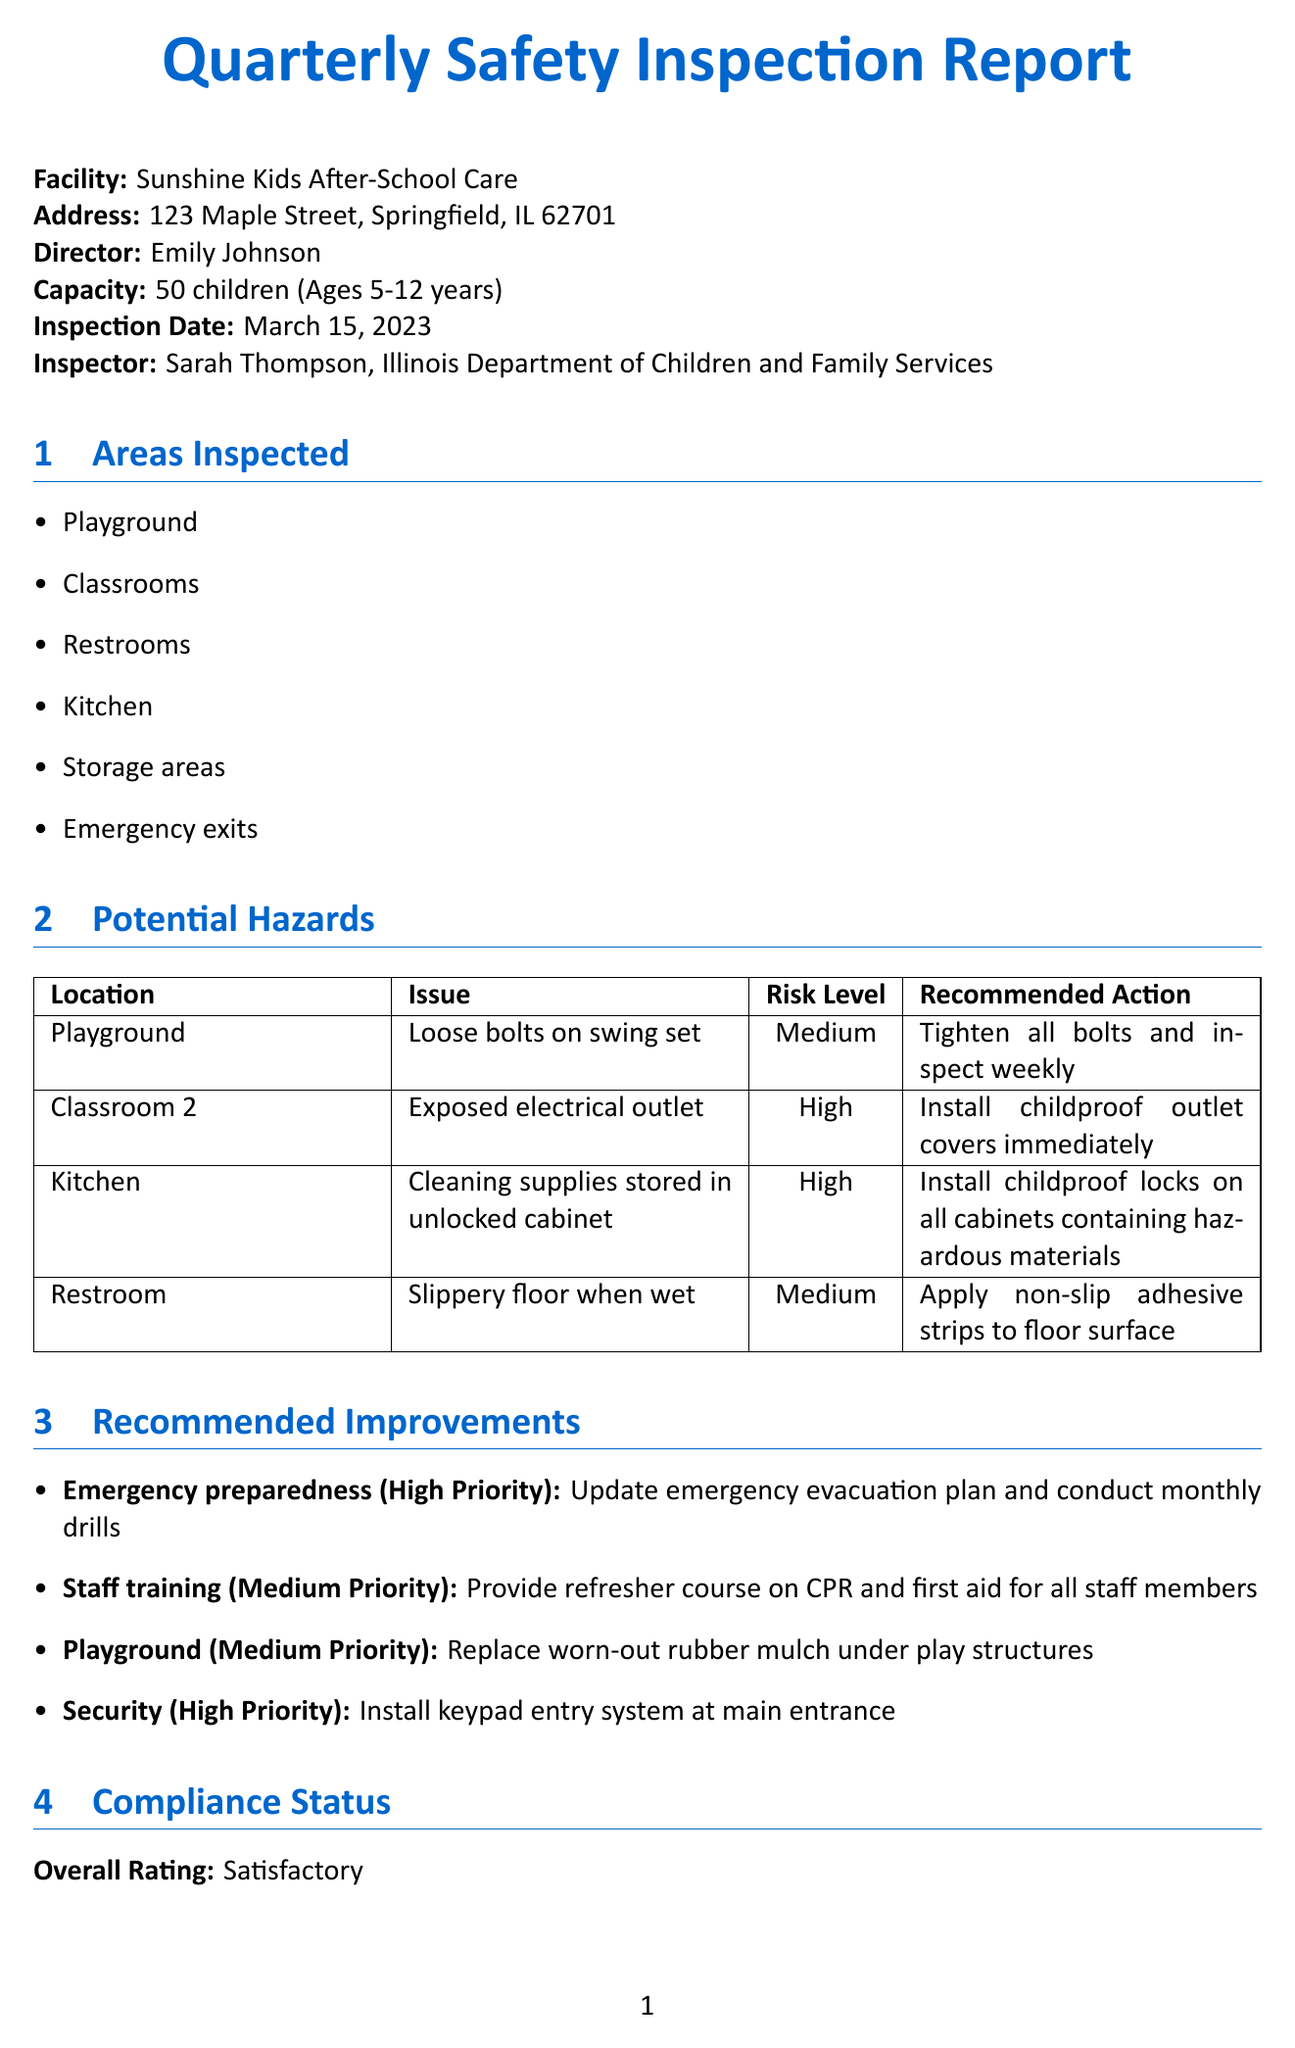What is the name of the facility? The name of the facility is provided at the beginning of the document.
Answer: Sunshine Kids After-School Care Who conducted the inspection? The inspector's name and organization are mentioned in the inspection details section.
Answer: Sarah Thompson What is the risk level associated with the exposed electrical outlet? The risk levels for each potential hazard are summarized in the potential hazards section.
Answer: High What action is recommended for the playground? The document lists the recommended actions for various hazards, including the playground.
Answer: Tighten all bolts and inspect weekly How many children can the facility accommodate? The capacity of the facility is specified in the facility information section.
Answer: 50 What is the overall rating of the compliance status? The overall rating can be found in the compliance status section.
Answer: Satisfactory What is one area that needs improvement? Areas needing improvement are outlined in the compliance status section.
Answer: Playground maintenance What is the priority of the security improvement? The priority levels for recommended improvements are clearly specified in the recommended improvements section.
Answer: High When should proof of completed high-priority improvements be submitted? The timeline for follow-up actions is detailed at the end of the document.
Answer: Within 30 days 